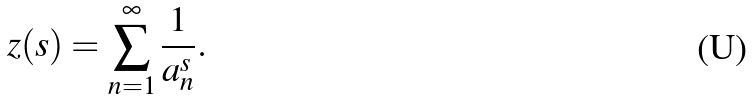Convert formula to latex. <formula><loc_0><loc_0><loc_500><loc_500>\ z ( s ) = \sum _ { n = 1 } ^ { \infty } \frac { 1 } { a _ { n } ^ { s } } .</formula> 